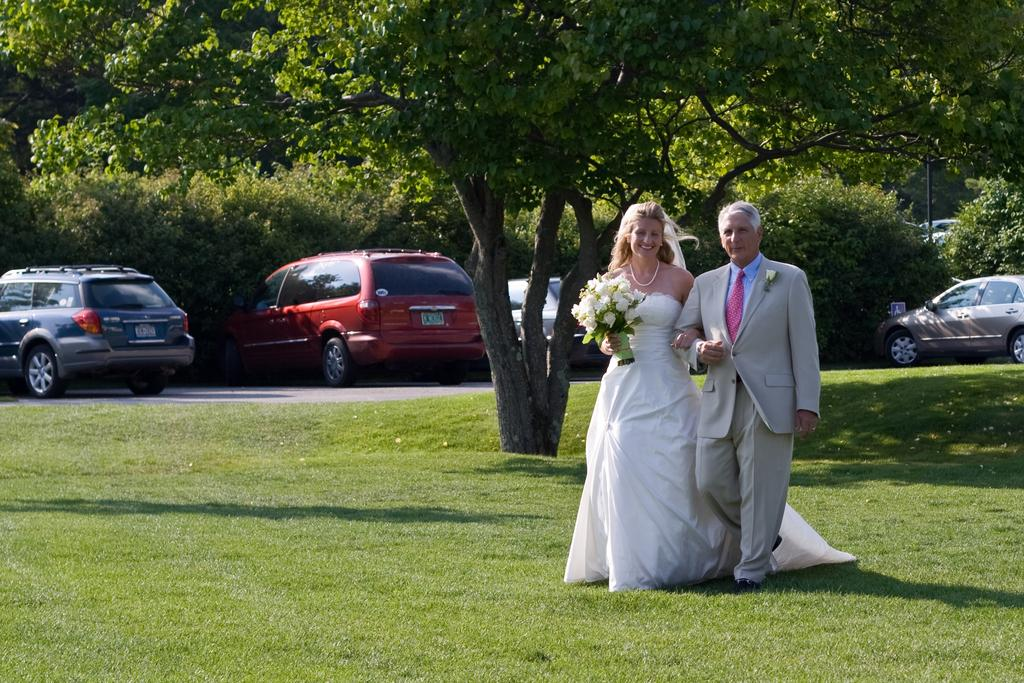Who are the two people in the image? There is a couple in the image. What is the setting of the image? The couple is standing on a greenery ground. What can be seen behind the couple? There is a tree behind the couple. What is visible in the background of the image? There are vehicles and trees in the background of the image. What type of rhythm can be heard from the border in the image? There is no border or rhythm present in the image. 